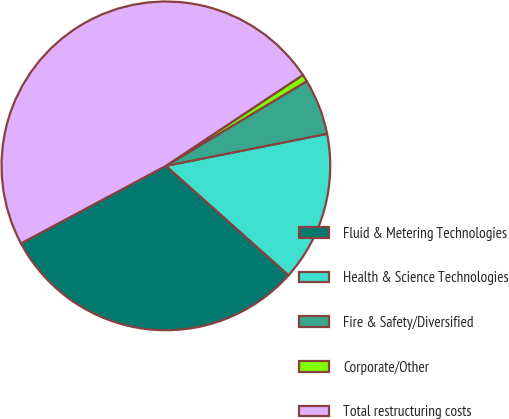Convert chart to OTSL. <chart><loc_0><loc_0><loc_500><loc_500><pie_chart><fcel>Fluid & Metering Technologies<fcel>Health & Science Technologies<fcel>Fire & Safety/Diversified<fcel>Corporate/Other<fcel>Total restructuring costs<nl><fcel>30.59%<fcel>14.71%<fcel>5.49%<fcel>0.71%<fcel>48.5%<nl></chart> 